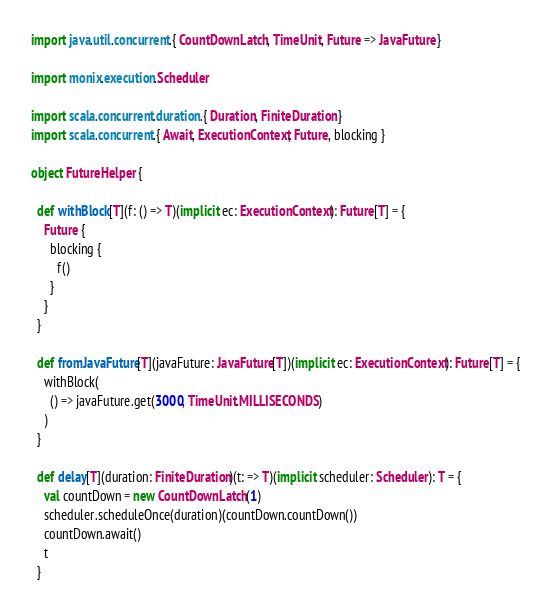<code> <loc_0><loc_0><loc_500><loc_500><_Scala_>import java.util.concurrent.{ CountDownLatch, TimeUnit, Future => JavaFuture }

import monix.execution.Scheduler

import scala.concurrent.duration.{ Duration, FiniteDuration }
import scala.concurrent.{ Await, ExecutionContext, Future, blocking }

object FutureHelper {

  def withBlock[T](f: () => T)(implicit ec: ExecutionContext): Future[T] = {
    Future {
      blocking {
        f()
      }
    }
  }

  def fromJavaFuture[T](javaFuture: JavaFuture[T])(implicit ec: ExecutionContext): Future[T] = {
    withBlock(
      () => javaFuture.get(3000, TimeUnit.MILLISECONDS)
    )
  }

  def delay[T](duration: FiniteDuration)(t: => T)(implicit scheduler: Scheduler): T = {
    val countDown = new CountDownLatch(1)
    scheduler.scheduleOnce(duration)(countDown.countDown())
    countDown.await()
    t
  }
</code> 